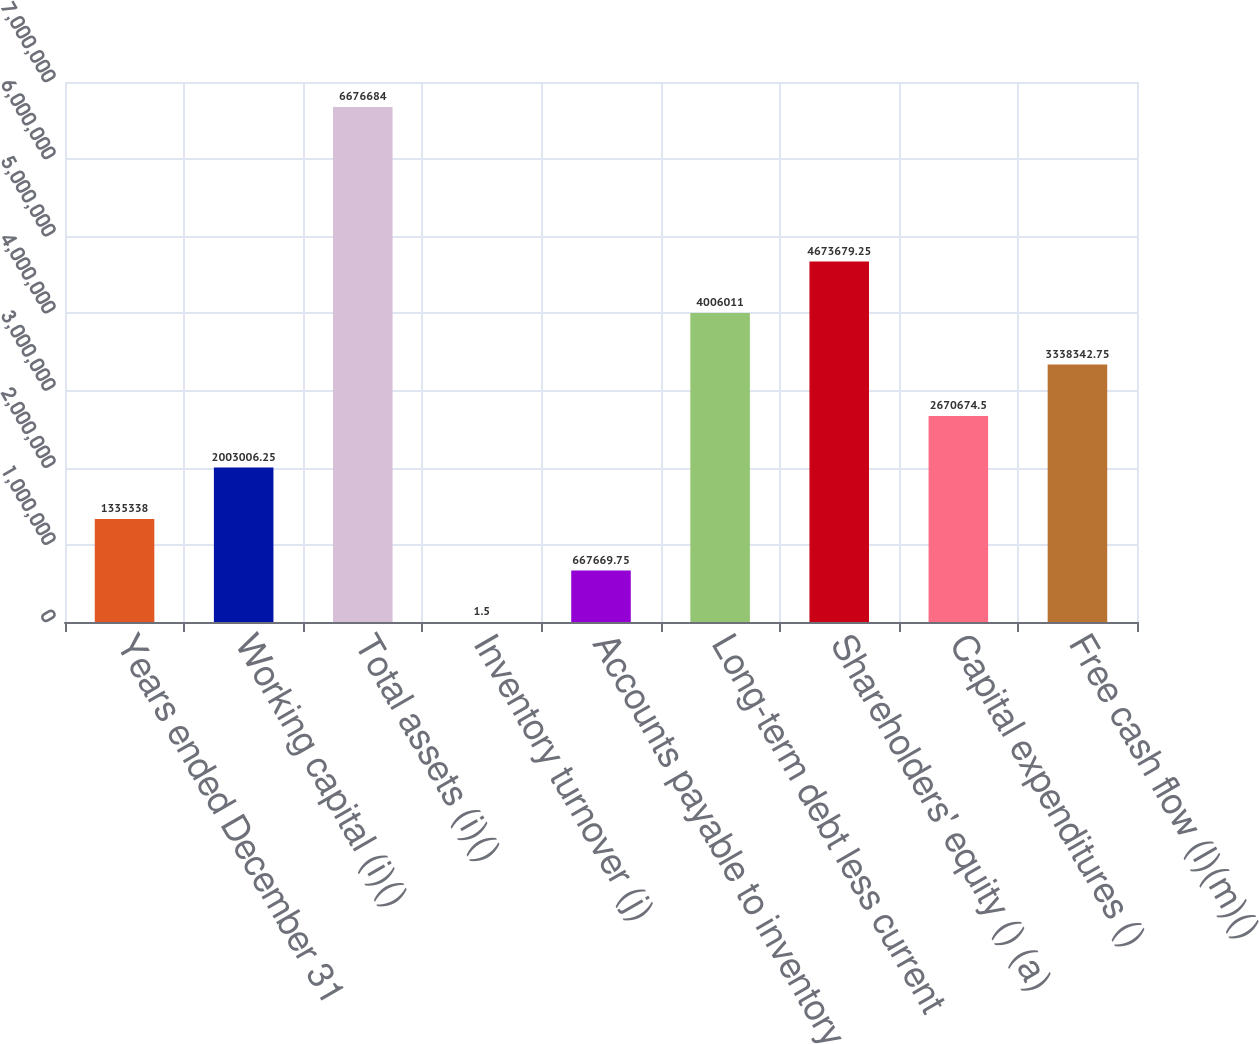Convert chart. <chart><loc_0><loc_0><loc_500><loc_500><bar_chart><fcel>Years ended December 31<fcel>Working capital (i)()<fcel>Total assets (i)()<fcel>Inventory turnover (j)<fcel>Accounts payable to inventory<fcel>Long-term debt less current<fcel>Shareholders' equity () (a)<fcel>Capital expenditures ()<fcel>Free cash flow (l)(m)()<nl><fcel>1.33534e+06<fcel>2.00301e+06<fcel>6.67668e+06<fcel>1.5<fcel>667670<fcel>4.00601e+06<fcel>4.67368e+06<fcel>2.67067e+06<fcel>3.33834e+06<nl></chart> 